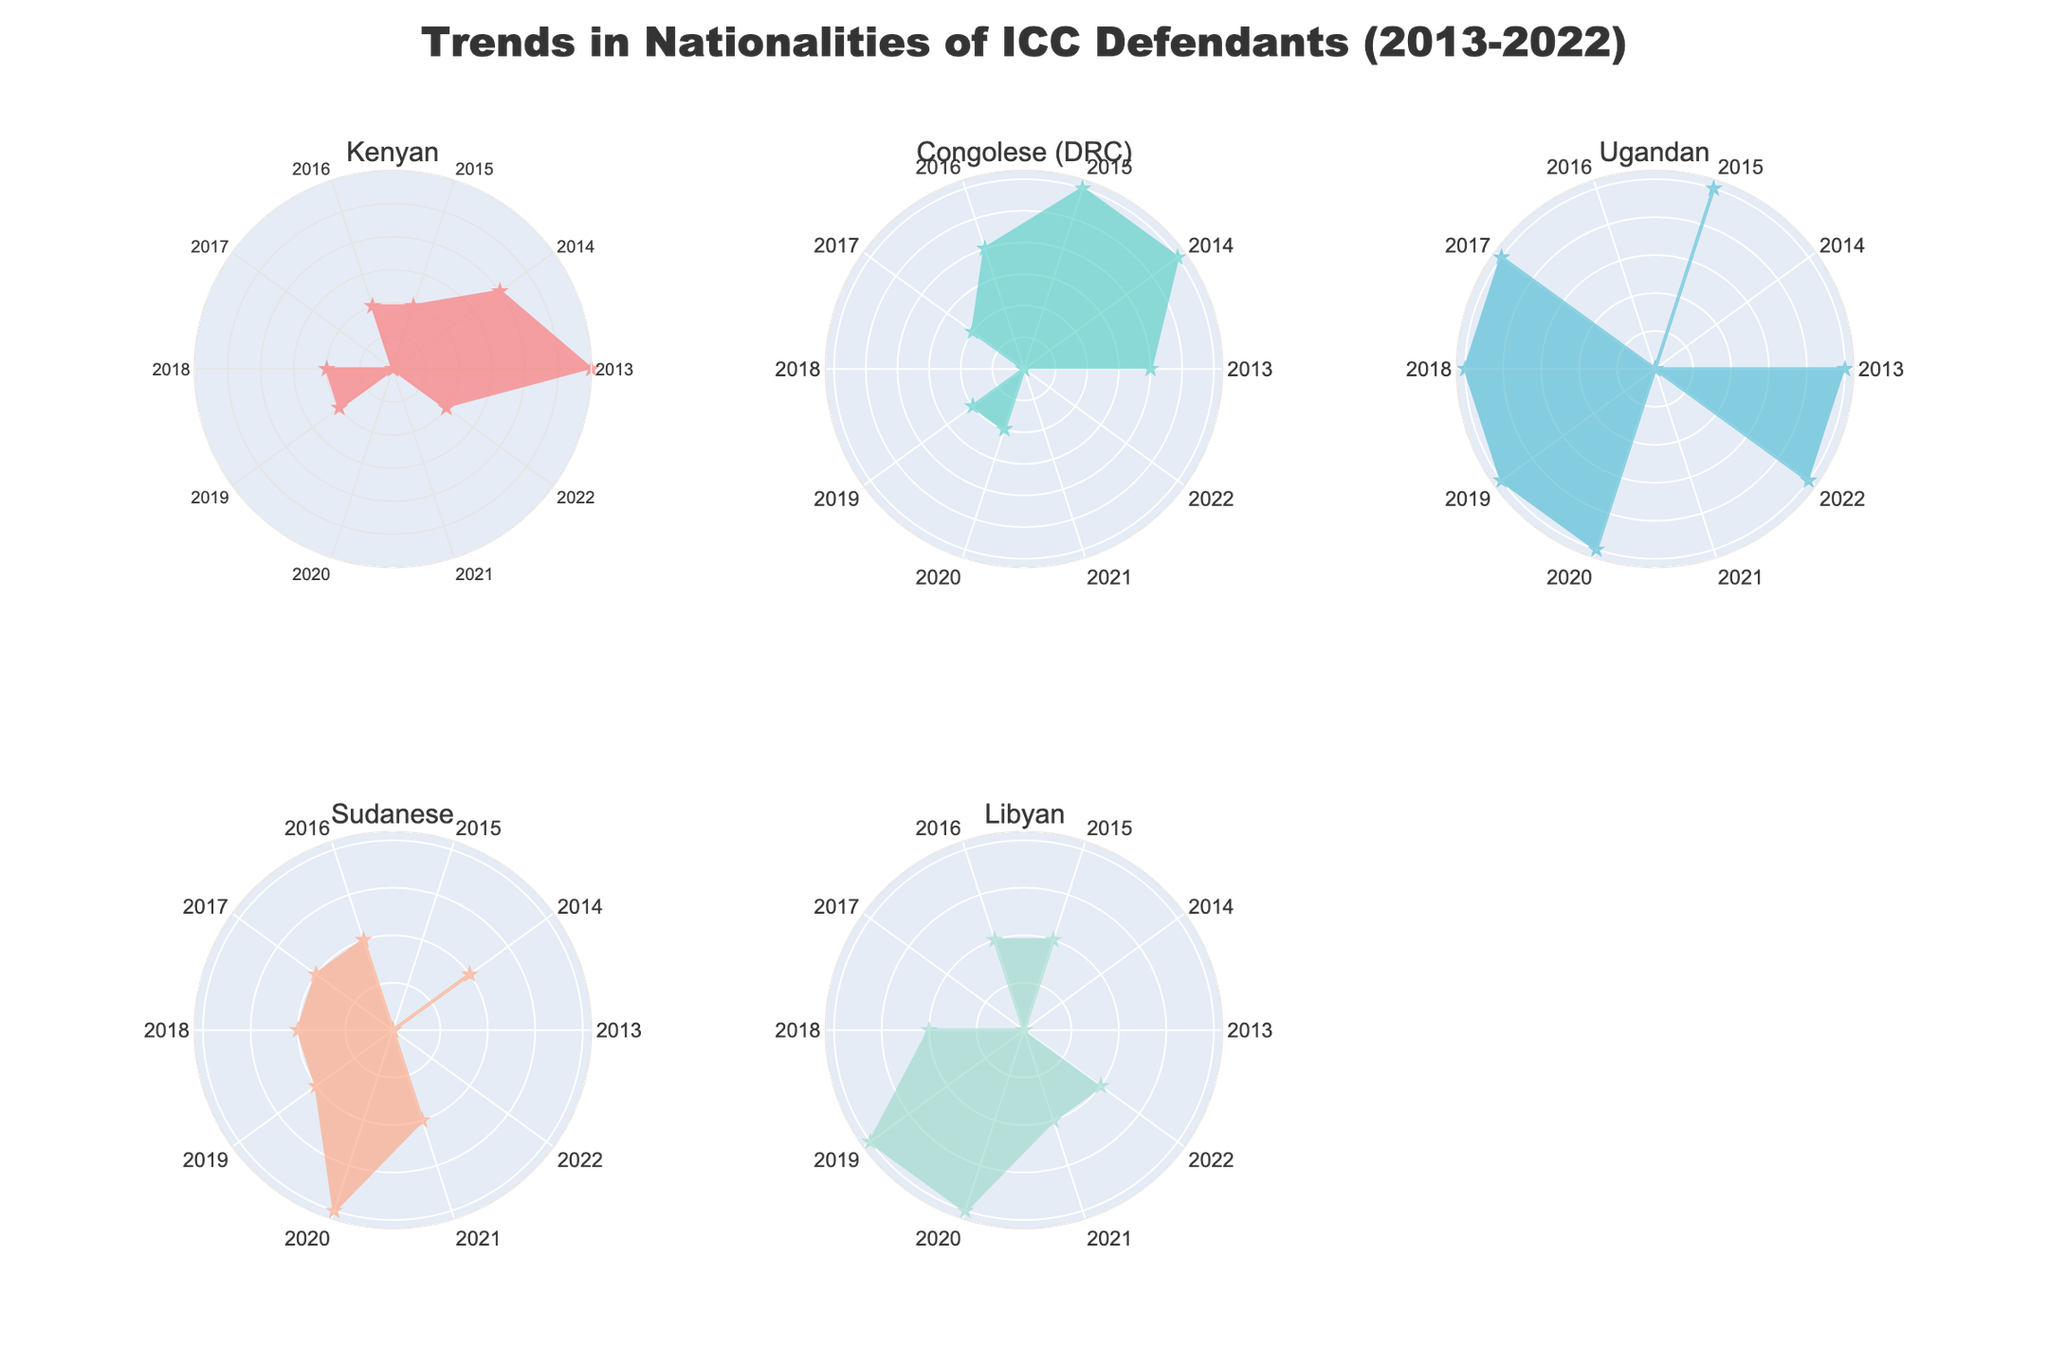How many nationalities are represented in the figure? By observing the subplot titles, we can count the distinct number of nationalities represented. Each subplot title corresponds to a different nationality.
Answer: 5 What is the title of the figure? The title is displayed prominently at the top center of the figure.
Answer: Trends in Nationalities of ICC Defendants (2013-2022) Which nationality had the highest count of defendants in any single year? By examining the radial extent of the plots in each polar subplot, the nationality with the highest count in any given year can be identified.
Answer: Kenyan What is the overall trend in the number of Kenyan defendants from 2013 to 2022? Analyzing the spread of counts over the years for Kenya shows that the counts peaked in 2013 and generally remained low afterward with occasional small peaks.
Answer: Declining In which year did Libyan defendants have the highest count? By looking at the radial axis for the Libyan subplot and identifying the year with the maximum radius, we can specify the year of the highest count.
Answer: 2019 and 2020 Compare the trend of Congolese (DRC) defendants with that of Ugandan defendants. Both trends show fluctuations, but Congolese (DRC) started high in 2013 and declined towards the end of the period, whereas Ugandan counts remained low but showed an increase starting from 2017.
Answer: Congolese (DRC) - Decreasing; Ugandan - Increasing What is the difference in the total number of defendants between Sudanese and Libyan nationalities from 2013 to 2022? Sum the counts for both Sudanese and Libyan nationalities over the years, then find the absolute difference between these totals.
Answer: 1 (Sudanese: 8, Libyan: 9) Which nationality had the most years with zero defendants? By identifying years with zero counts in each subplot, we can determine the nationality with the highest number of such years.
Answer: Kenyan and Libyan How many nationalities had a year with exactly two defendants? Count the number of nationalities where the polar chart shows a radius reaching the value representing "2" on the radial axis.
Answer: 3 What color is used to represent Ugandan defendants? The subplot title for Ugandan links directly to the color used in its respective polar chart.
Answer: Light blue 